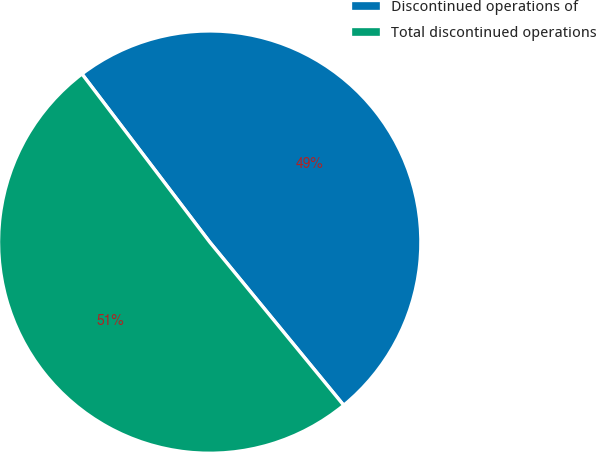Convert chart. <chart><loc_0><loc_0><loc_500><loc_500><pie_chart><fcel>Discontinued operations of<fcel>Total discontinued operations<nl><fcel>49.4%<fcel>50.6%<nl></chart> 